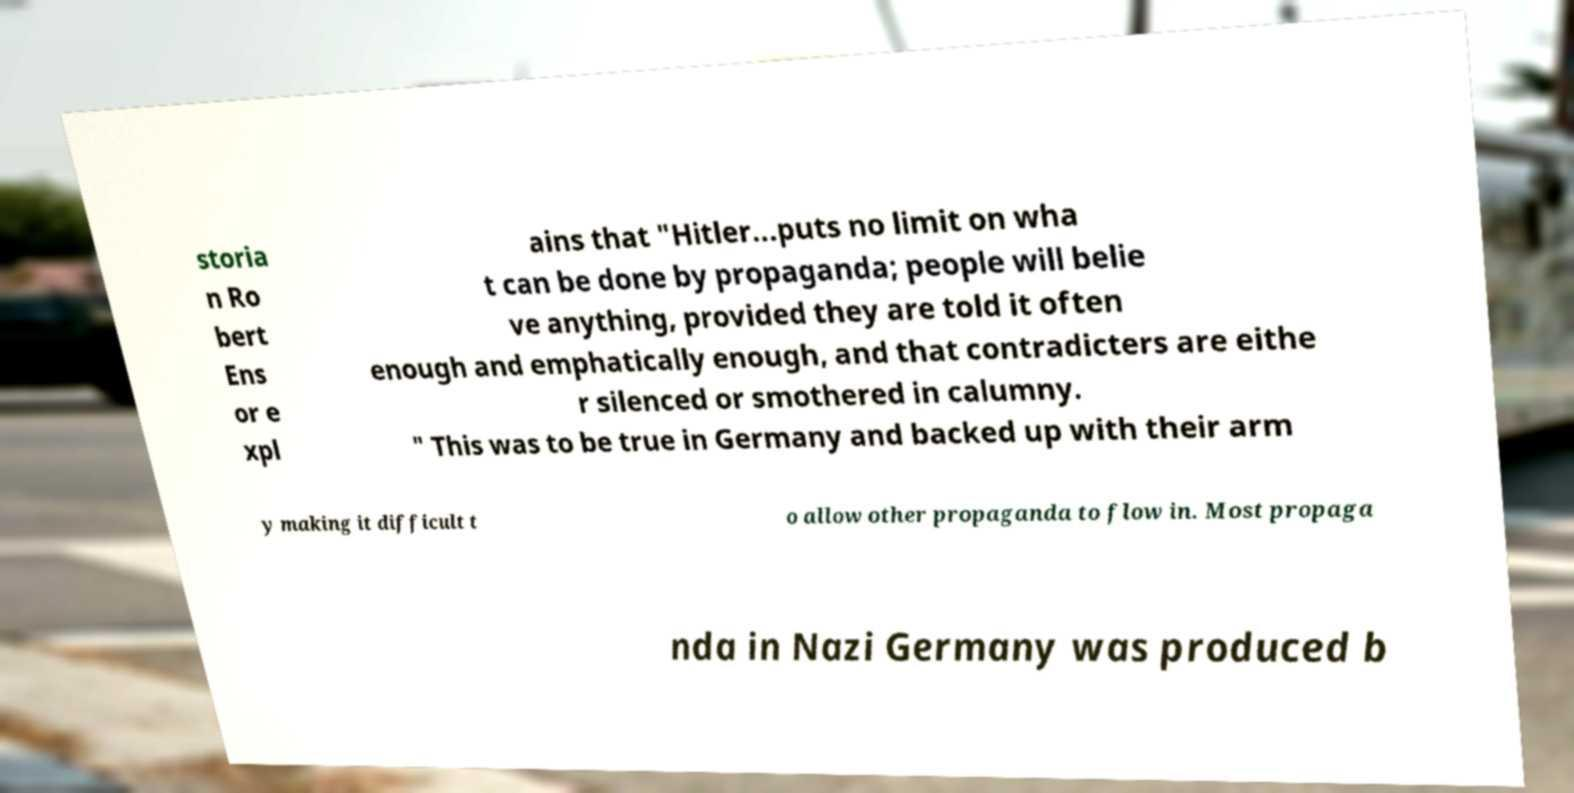I need the written content from this picture converted into text. Can you do that? storia n Ro bert Ens or e xpl ains that "Hitler...puts no limit on wha t can be done by propaganda; people will belie ve anything, provided they are told it often enough and emphatically enough, and that contradicters are eithe r silenced or smothered in calumny. " This was to be true in Germany and backed up with their arm y making it difficult t o allow other propaganda to flow in. Most propaga nda in Nazi Germany was produced b 